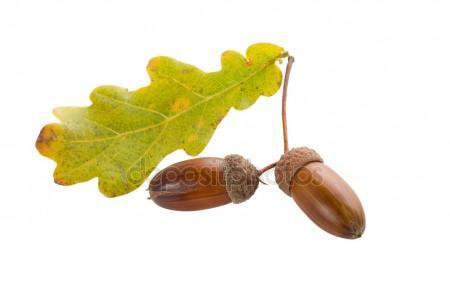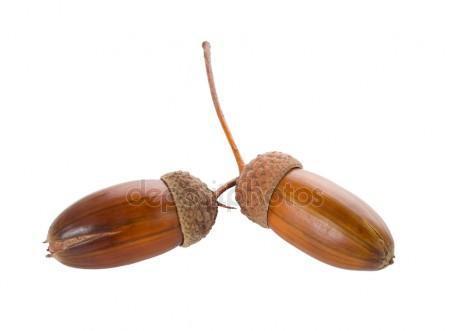The first image is the image on the left, the second image is the image on the right. Given the left and right images, does the statement "There are four acorns with brown tops." hold true? Answer yes or no. Yes. The first image is the image on the left, the second image is the image on the right. Assess this claim about the two images: "Each image contains one pair of acorns with their caps on, and no image contains a leaf.". Correct or not? Answer yes or no. No. 